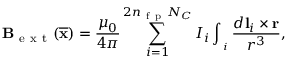Convert formula to latex. <formula><loc_0><loc_0><loc_500><loc_500>\mathbf B _ { e x t } ( \overline { \mathbf x } ) = \frac { \mu _ { 0 } } { 4 \pi } \sum _ { i = 1 } ^ { 2 n _ { f p } N _ { C } } I _ { i } \int _ { \mathbf \Gamma _ { i } } \frac { d \mathbf l _ { i } \times \mathbf r } { r ^ { 3 } } ,</formula> 